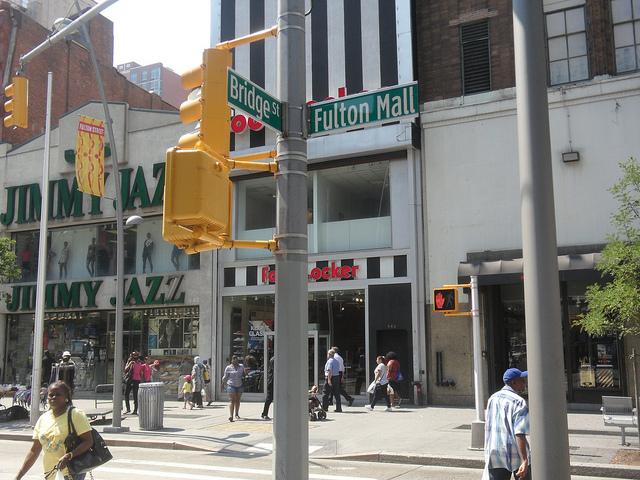What is the pattern on the building?
Give a very brief answer. Stripes. Is this cross-section crowded?
Answer briefly. No. What would that wall be?
Short answer required. Store. What store has a green sign?
Quick response, please. Jimmy jazz. 